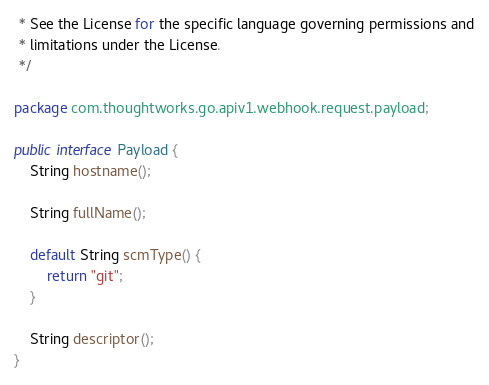Convert code to text. <code><loc_0><loc_0><loc_500><loc_500><_Java_> * See the License for the specific language governing permissions and
 * limitations under the License.
 */

package com.thoughtworks.go.apiv1.webhook.request.payload;

public interface Payload {
    String hostname();

    String fullName();

    default String scmType() {
        return "git";
    }

    String descriptor();
}
</code> 